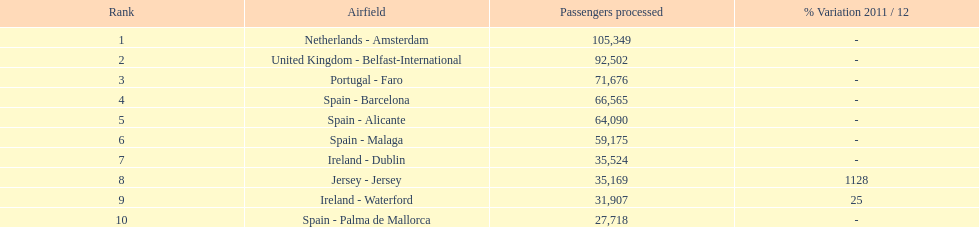Write the full table. {'header': ['Rank', 'Airfield', 'Passengers processed', '% Variation 2011 / 12'], 'rows': [['1', 'Netherlands - Amsterdam', '105,349', '-'], ['2', 'United Kingdom - Belfast-International', '92,502', '-'], ['3', 'Portugal - Faro', '71,676', '-'], ['4', 'Spain - Barcelona', '66,565', '-'], ['5', 'Spain - Alicante', '64,090', '-'], ['6', 'Spain - Malaga', '59,175', '-'], ['7', 'Ireland - Dublin', '35,524', '-'], ['8', 'Jersey - Jersey', '35,169', '1128'], ['9', 'Ireland - Waterford', '31,907', '25'], ['10', 'Spain - Palma de Mallorca', '27,718', '-']]} Between the topped ranked airport, netherlands - amsterdam, & spain - palma de mallorca, what is the difference in the amount of passengers handled? 77,631. 